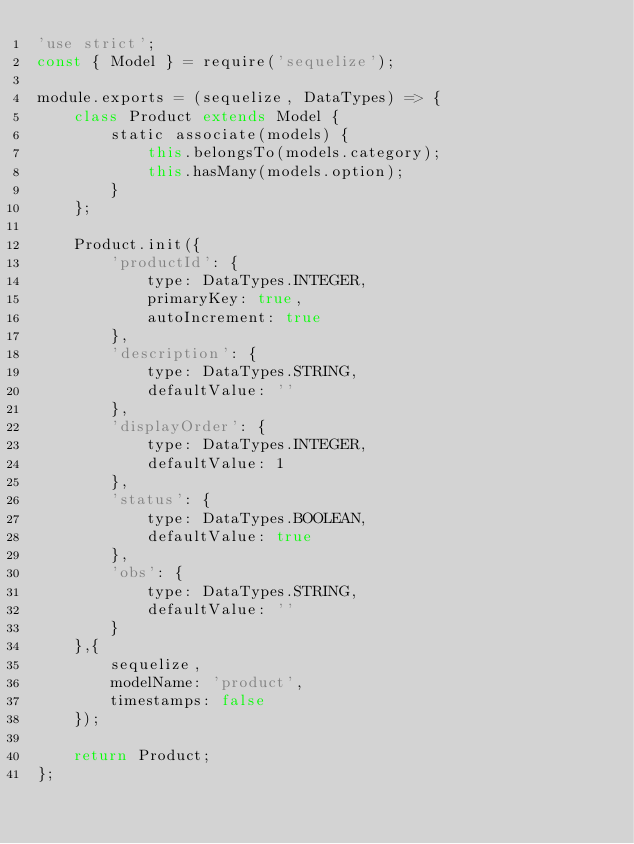<code> <loc_0><loc_0><loc_500><loc_500><_JavaScript_>'use strict';
const { Model } = require('sequelize');

module.exports = (sequelize, DataTypes) => {
    class Product extends Model {
        static associate(models) {
            this.belongsTo(models.category);
            this.hasMany(models.option);
        }
    };

    Product.init({
		'productId': {
			type: DataTypes.INTEGER,
			primaryKey: true,
			autoIncrement: true
		},
		'description': {
			type: DataTypes.STRING,
			defaultValue: ''
        },
        'displayOrder': {
            type: DataTypes.INTEGER,
            defaultValue: 1
        }, 
        'status': {
            type: DataTypes.BOOLEAN,
            defaultValue: true
        },
        'obs': {
            type: DataTypes.STRING,
            defaultValue: ''
        }
    },{
        sequelize,
        modelName: 'product',
        timestamps: false
    });

    return Product;
};</code> 